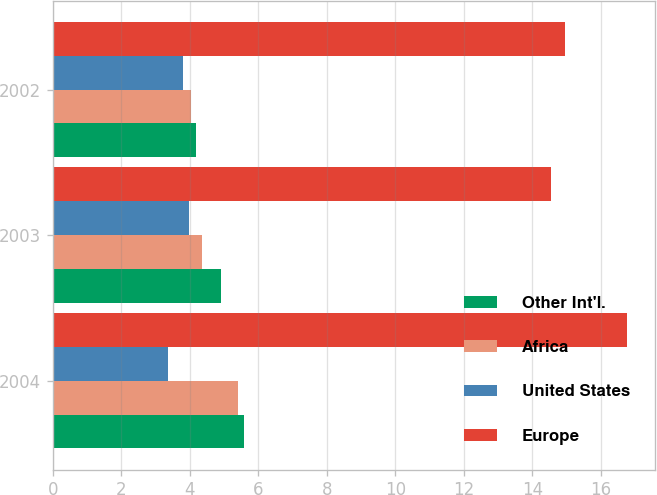Convert chart. <chart><loc_0><loc_0><loc_500><loc_500><stacked_bar_chart><ecel><fcel>2004<fcel>2003<fcel>2002<nl><fcel>Other Int'l.<fcel>5.58<fcel>4.92<fcel>4.17<nl><fcel>Africa<fcel>5.39<fcel>4.35<fcel>4.03<nl><fcel>United States<fcel>3.35<fcel>3.98<fcel>3.81<nl><fcel>Europe<fcel>16.76<fcel>14.56<fcel>14.95<nl></chart> 